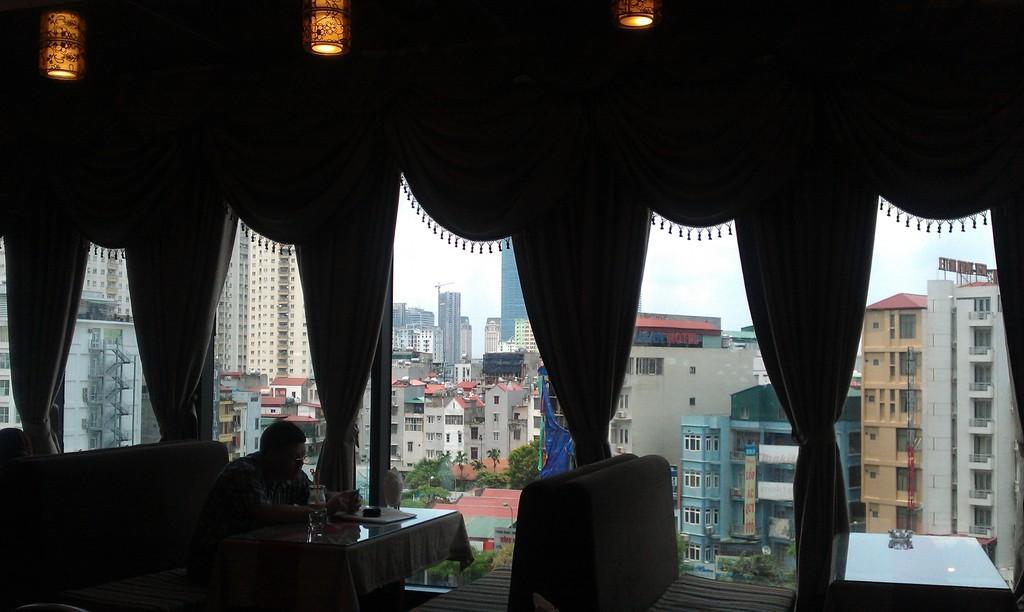Please provide a concise description of this image. In this picture there is a man sitting on the chair. There is a bottle on the table. There is a white curtain. There is a light on the roof. There is a bowl on the table. There is a building at the background and a house. There are some trees at the background. 